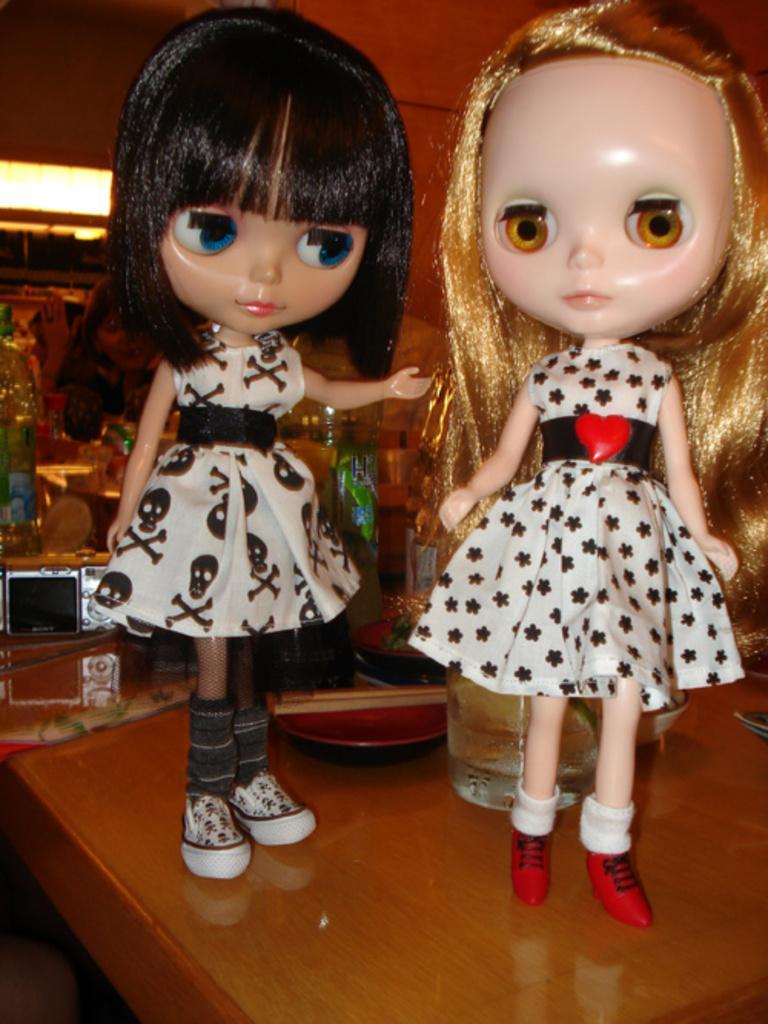In one or two sentences, can you explain what this image depicts? In this image there are two dolls on the table. There are glass and plate. There are few objects in the background. 